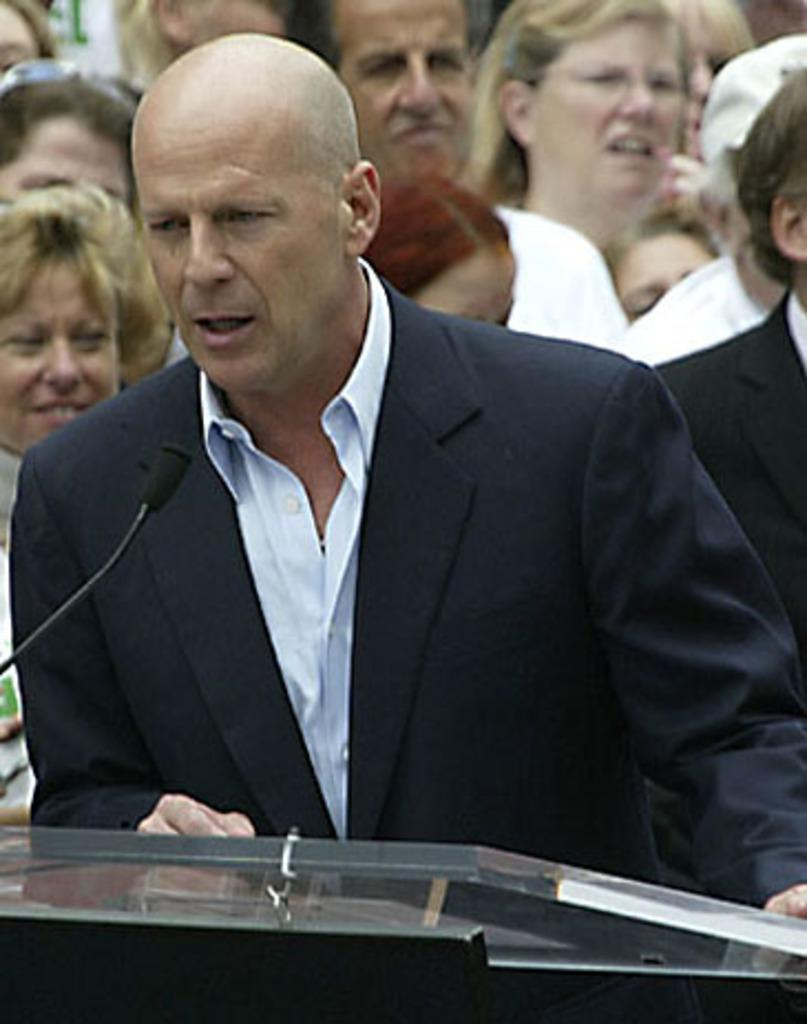How many people are in the image? There is a group of people in the image. What is the man with a mic doing in the image? The man with a mic is standing in front of a podium. What might the man with a mic be doing at the podium? The man with a mic might be giving a speech or presentation at the podium. Can you see the receipt for the cream in the image? There is no mention of a receipt or cream in the image, so we cannot see a receipt for the cream. 